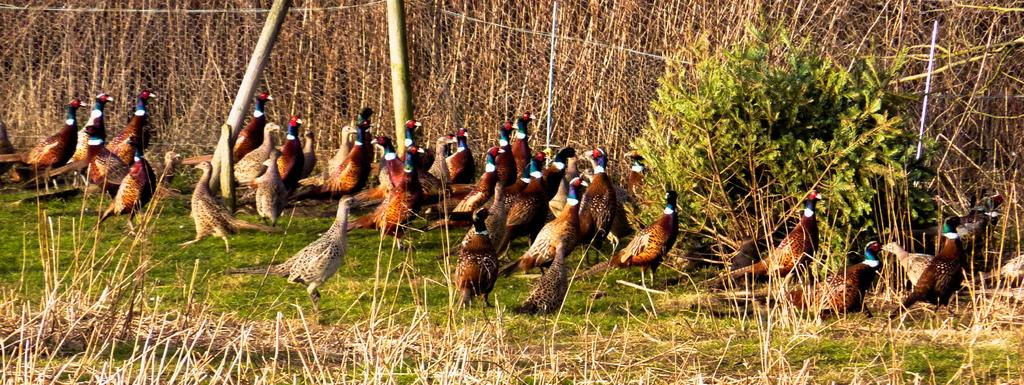What type of animals can be seen in the image? There are birds in the image. What is located behind the birds? There is fencing behind the birds. What type of vegetation is present in the image? There are plants in the image. What type of ground cover can be seen in the image? There is grass in the image. What type of brass instrument is being played by the birds in the image? There is no brass instrument present in the image, and the birds are not playing any instruments. 